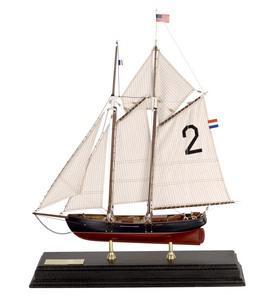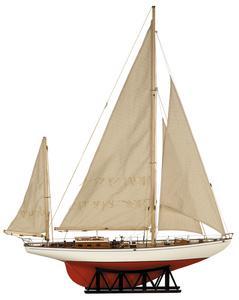The first image is the image on the left, the second image is the image on the right. Analyze the images presented: Is the assertion "A boat on the water with three inflated sails is facing left" valid? Answer yes or no. No. 